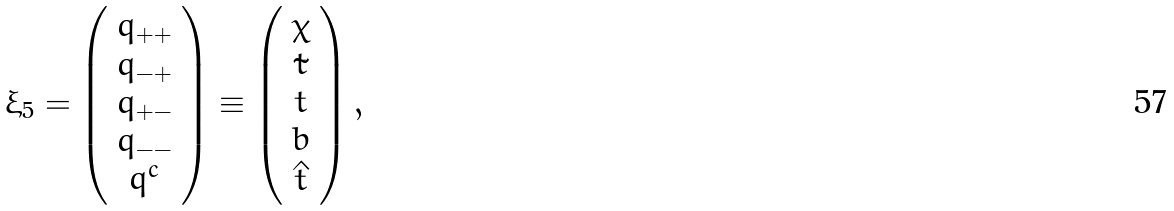Convert formula to latex. <formula><loc_0><loc_0><loc_500><loc_500>\xi _ { 5 } = \left ( \begin{array} { c } q _ { + + } \\ q _ { - + } \\ q _ { + - } \\ q _ { - - } \\ q ^ { c } \end{array} \right ) \equiv \left ( \begin{array} { c } \chi \\ \tilde { t } \\ t \\ b \\ \hat { t } \end{array} \right ) ,</formula> 